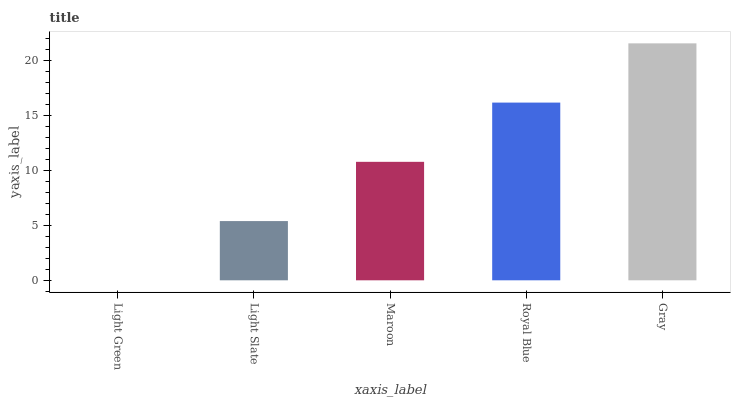Is Light Slate the minimum?
Answer yes or no. No. Is Light Slate the maximum?
Answer yes or no. No. Is Light Slate greater than Light Green?
Answer yes or no. Yes. Is Light Green less than Light Slate?
Answer yes or no. Yes. Is Light Green greater than Light Slate?
Answer yes or no. No. Is Light Slate less than Light Green?
Answer yes or no. No. Is Maroon the high median?
Answer yes or no. Yes. Is Maroon the low median?
Answer yes or no. Yes. Is Gray the high median?
Answer yes or no. No. Is Gray the low median?
Answer yes or no. No. 